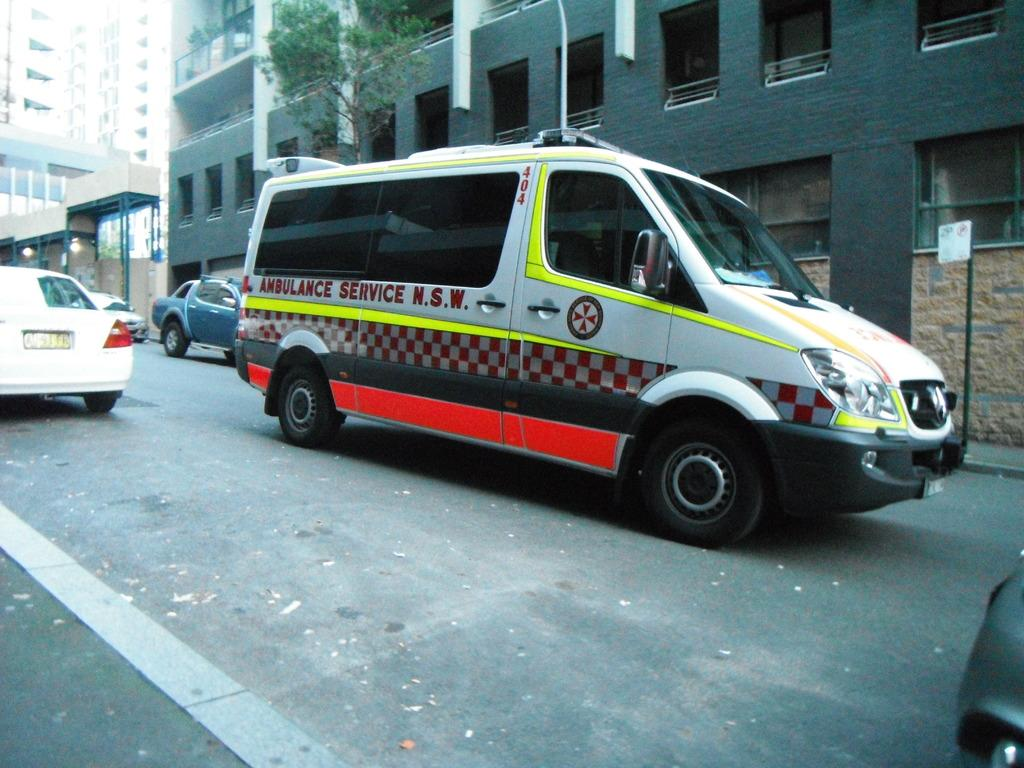Provide a one-sentence caption for the provided image. A white ambulance has the abbreviation N.S.W. painted on the side door. 